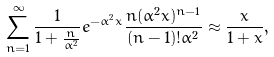Convert formula to latex. <formula><loc_0><loc_0><loc_500><loc_500>\sum _ { n = 1 } ^ { \infty } \frac { 1 } { 1 + \frac { n } { \alpha ^ { 2 } } } e ^ { - \alpha ^ { 2 } x } \frac { n ( \alpha ^ { 2 } x ) ^ { n - 1 } } { ( n - 1 ) ! \alpha ^ { 2 } } \approx \frac { x } { 1 + x } ,</formula> 